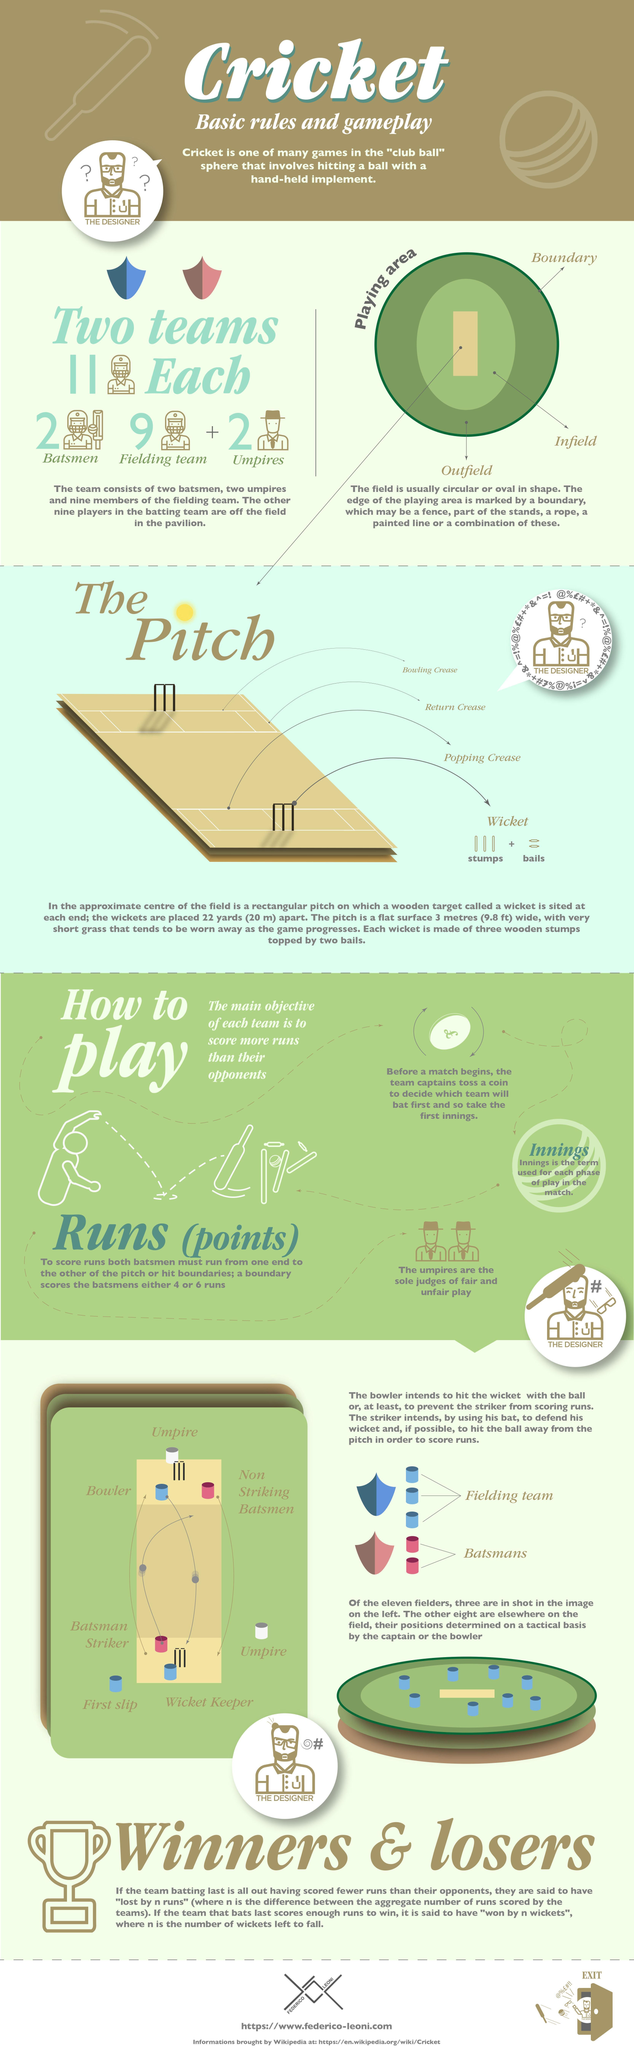What is the circular or oval area just outside of the pitch called?
Answer the question with a short phrase. infield What is the name of the rectangular strip at the center of the playing area? pitch How many players in each team? 11 What is the name for the outer perimeter of the playing field marked by a rope or painted line? boundary Which area comes between the boundary and the infield? outfield 